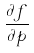Convert formula to latex. <formula><loc_0><loc_0><loc_500><loc_500>\frac { \partial f } { \partial p }</formula> 